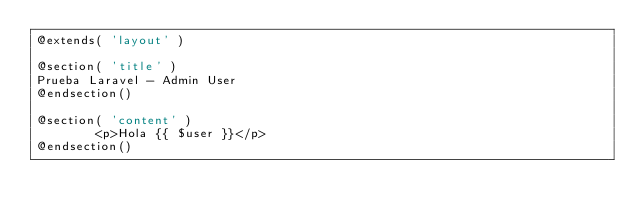Convert code to text. <code><loc_0><loc_0><loc_500><loc_500><_PHP_>@extends( 'layout' )

@section( 'title' )
Prueba Laravel - Admin User
@endsection()

@section( 'content' )
        <p>Hola {{ $user }}</p>
@endsection()</code> 